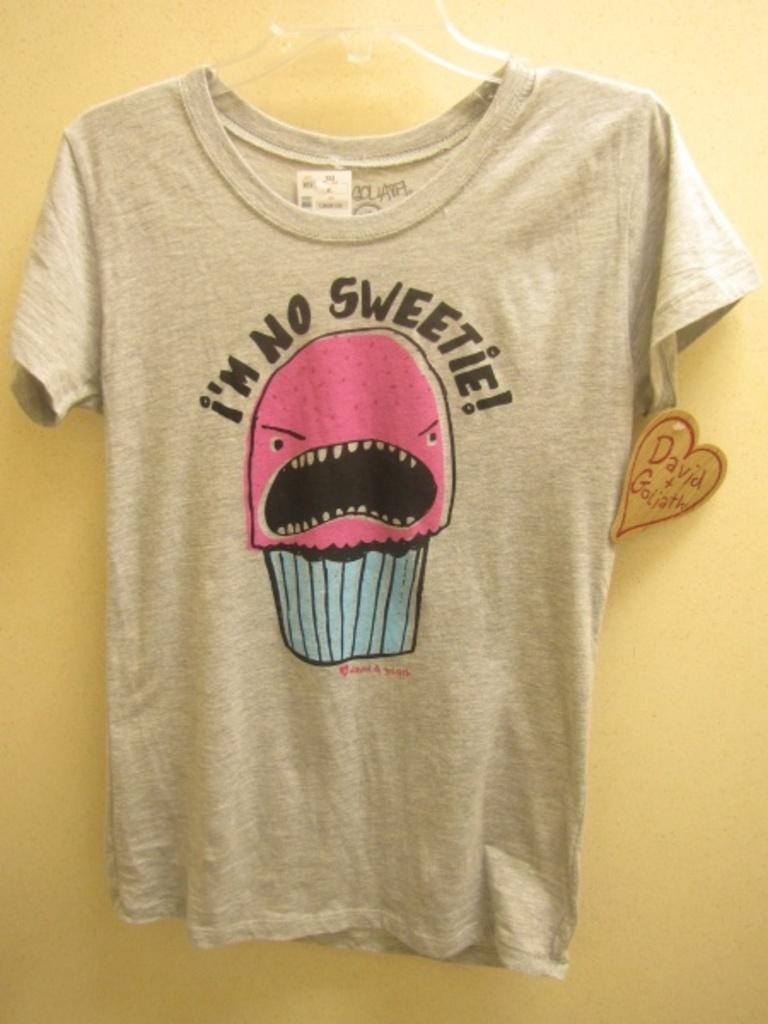What is hanging on the wall in the image? There is a shirt in the image, and it is hung on the wall. What color is the shirt? The shirt is in ash color. What is written on the shirt? The text "I'm no sweetie" is written on the shirt. What color is the wall? The wall is in yellow color. What type of spark can be seen in the cemetery in the image? There is no cemetery or spark present in the image; it features a shirt hung on a yellow wall. 